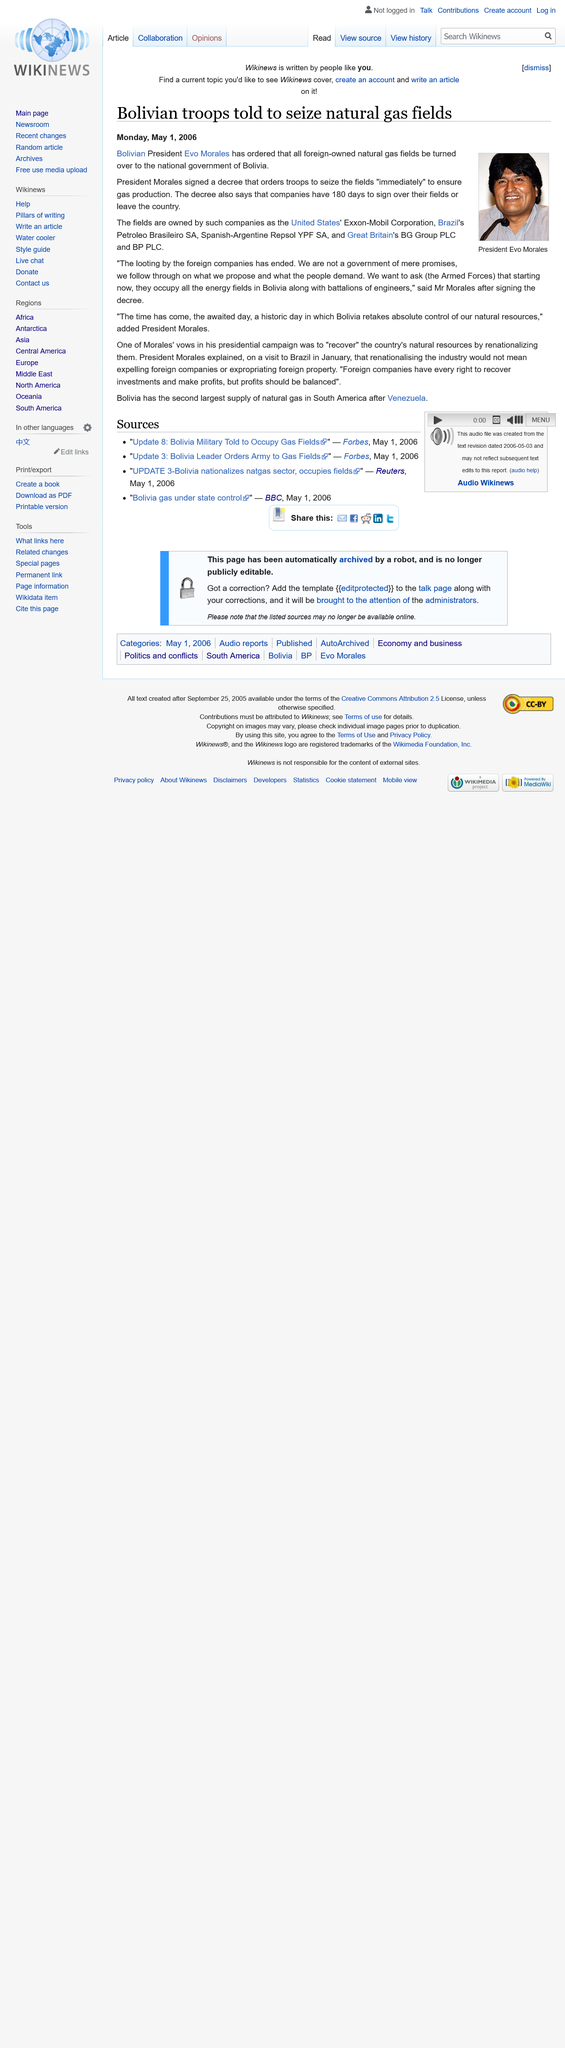Outline some significant characteristics in this image. Bolivian troops were instructed to seize control of the country's natural gas fields. The President depicted in the image to the left is named President Evo Morales. The decree stated that troops were to seize the fields immediately. 